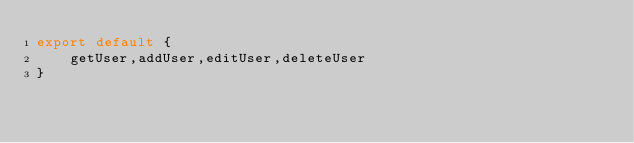<code> <loc_0><loc_0><loc_500><loc_500><_TypeScript_>export default {
    getUser,addUser,editUser,deleteUser
}</code> 